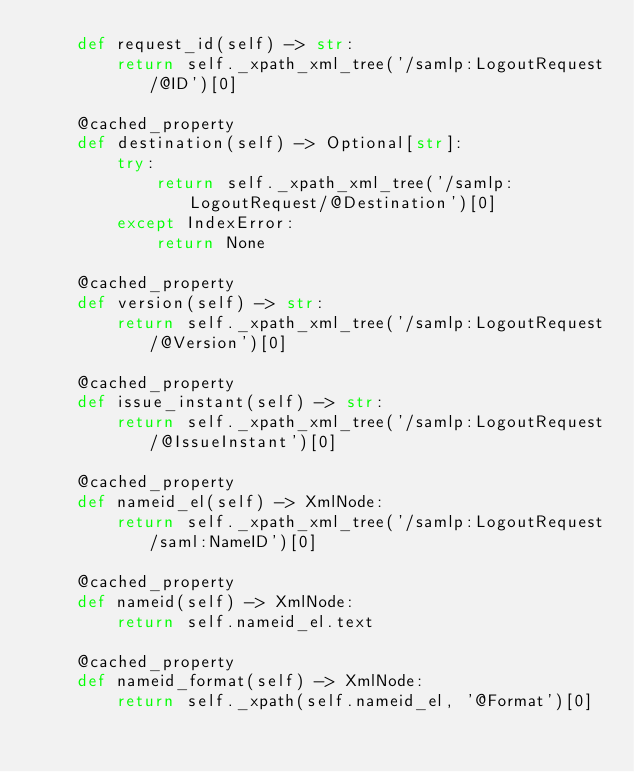<code> <loc_0><loc_0><loc_500><loc_500><_Python_>    def request_id(self) -> str:
        return self._xpath_xml_tree('/samlp:LogoutRequest/@ID')[0]

    @cached_property
    def destination(self) -> Optional[str]:
        try:
            return self._xpath_xml_tree('/samlp:LogoutRequest/@Destination')[0]
        except IndexError:
            return None

    @cached_property
    def version(self) -> str:
        return self._xpath_xml_tree('/samlp:LogoutRequest/@Version')[0]

    @cached_property
    def issue_instant(self) -> str:
        return self._xpath_xml_tree('/samlp:LogoutRequest/@IssueInstant')[0]

    @cached_property
    def nameid_el(self) -> XmlNode:
        return self._xpath_xml_tree('/samlp:LogoutRequest/saml:NameID')[0]

    @cached_property
    def nameid(self) -> XmlNode:
        return self.nameid_el.text

    @cached_property
    def nameid_format(self) -> XmlNode:
        return self._xpath(self.nameid_el, '@Format')[0]
</code> 